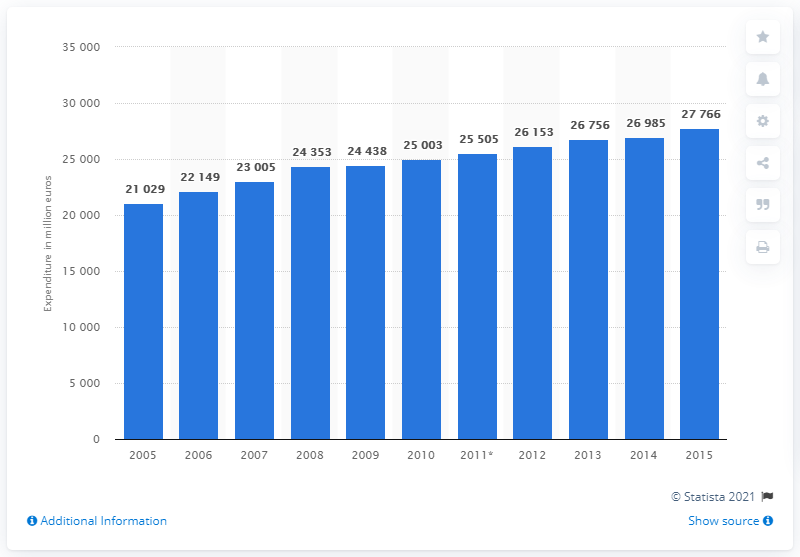List a handful of essential elements in this visual. The annual value of consumer spending on food in the Netherlands was approximately 27,766 million euros from 2005 to 2015. 